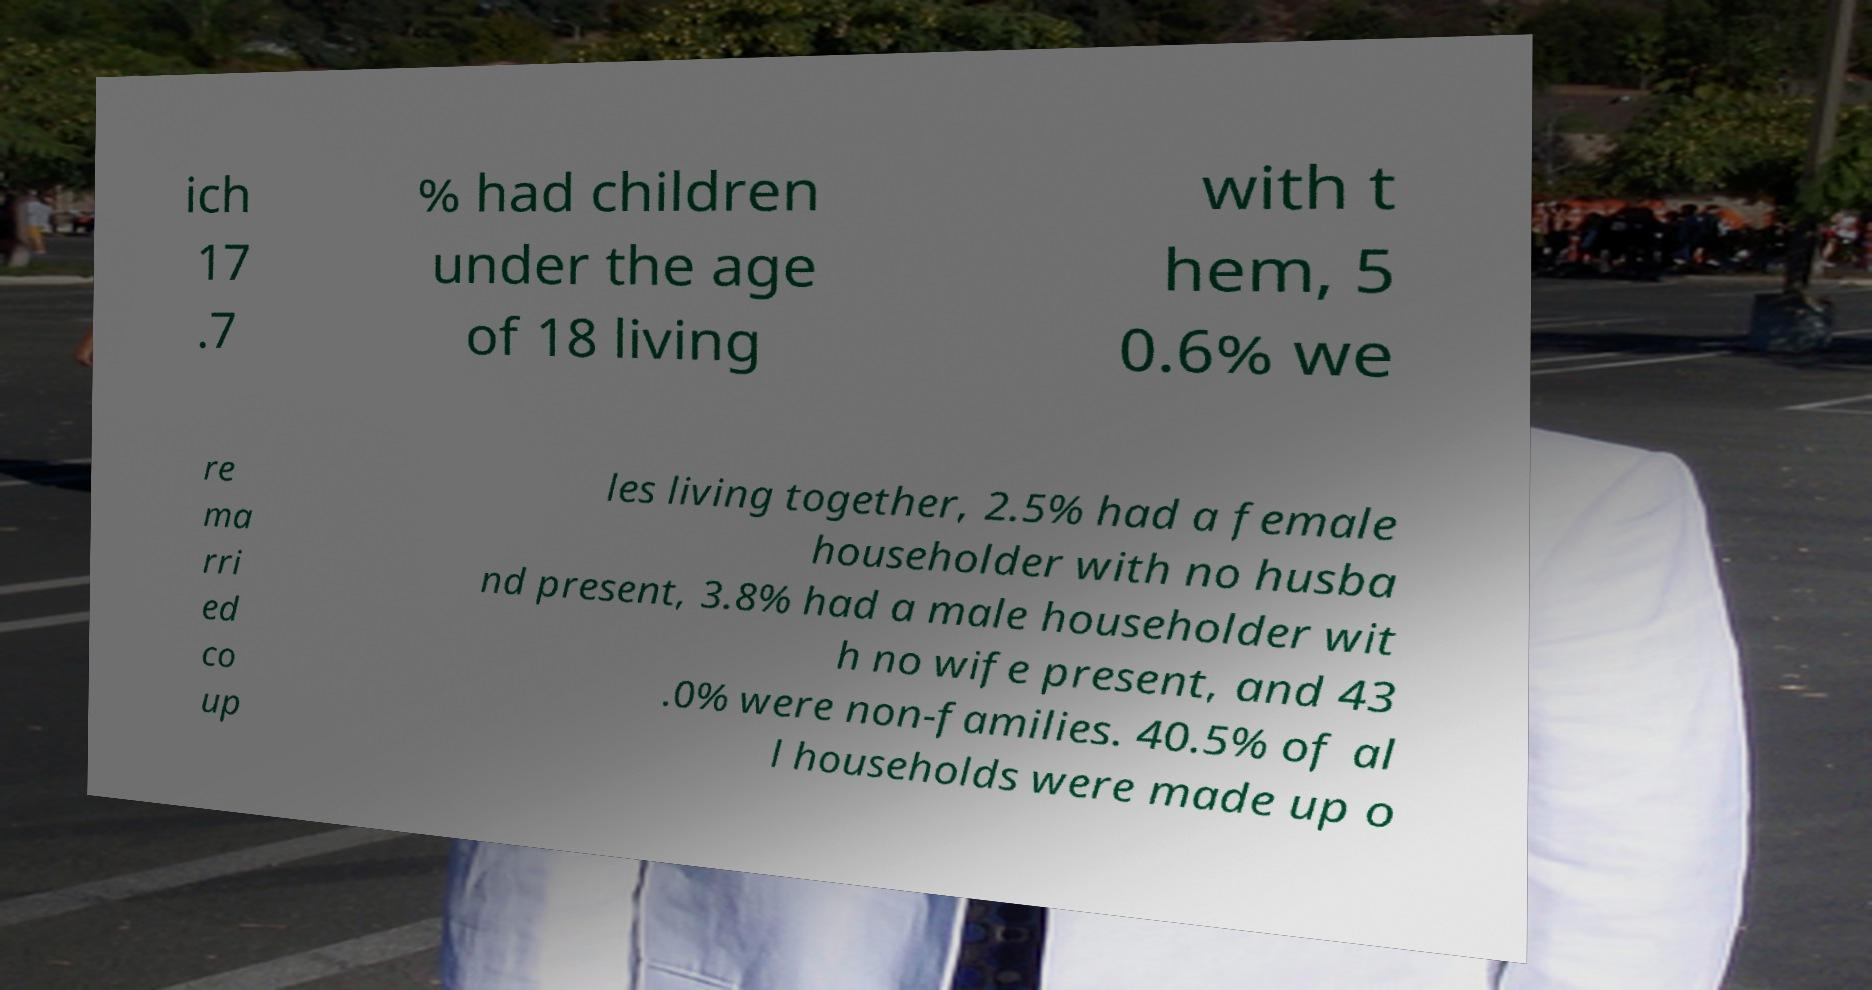Could you assist in decoding the text presented in this image and type it out clearly? ich 17 .7 % had children under the age of 18 living with t hem, 5 0.6% we re ma rri ed co up les living together, 2.5% had a female householder with no husba nd present, 3.8% had a male householder wit h no wife present, and 43 .0% were non-families. 40.5% of al l households were made up o 